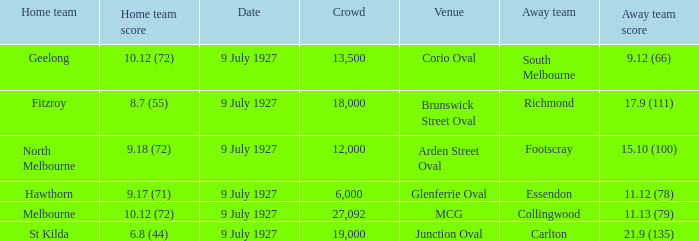How large was the crowd at Brunswick Street Oval? 18000.0. 